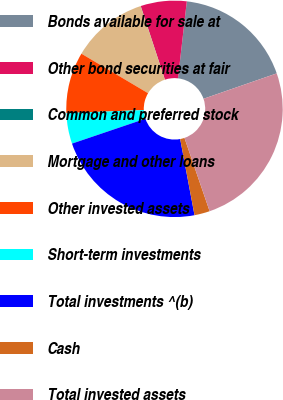<chart> <loc_0><loc_0><loc_500><loc_500><pie_chart><fcel>Bonds available for sale at<fcel>Other bond securities at fair<fcel>Common and preferred stock<fcel>Mortgage and other loans<fcel>Other invested assets<fcel>Short-term investments<fcel>Total investments ^(b)<fcel>Cash<fcel>Total invested assets<nl><fcel>17.87%<fcel>6.86%<fcel>0.02%<fcel>11.42%<fcel>9.14%<fcel>4.58%<fcel>22.76%<fcel>2.3%<fcel>25.05%<nl></chart> 